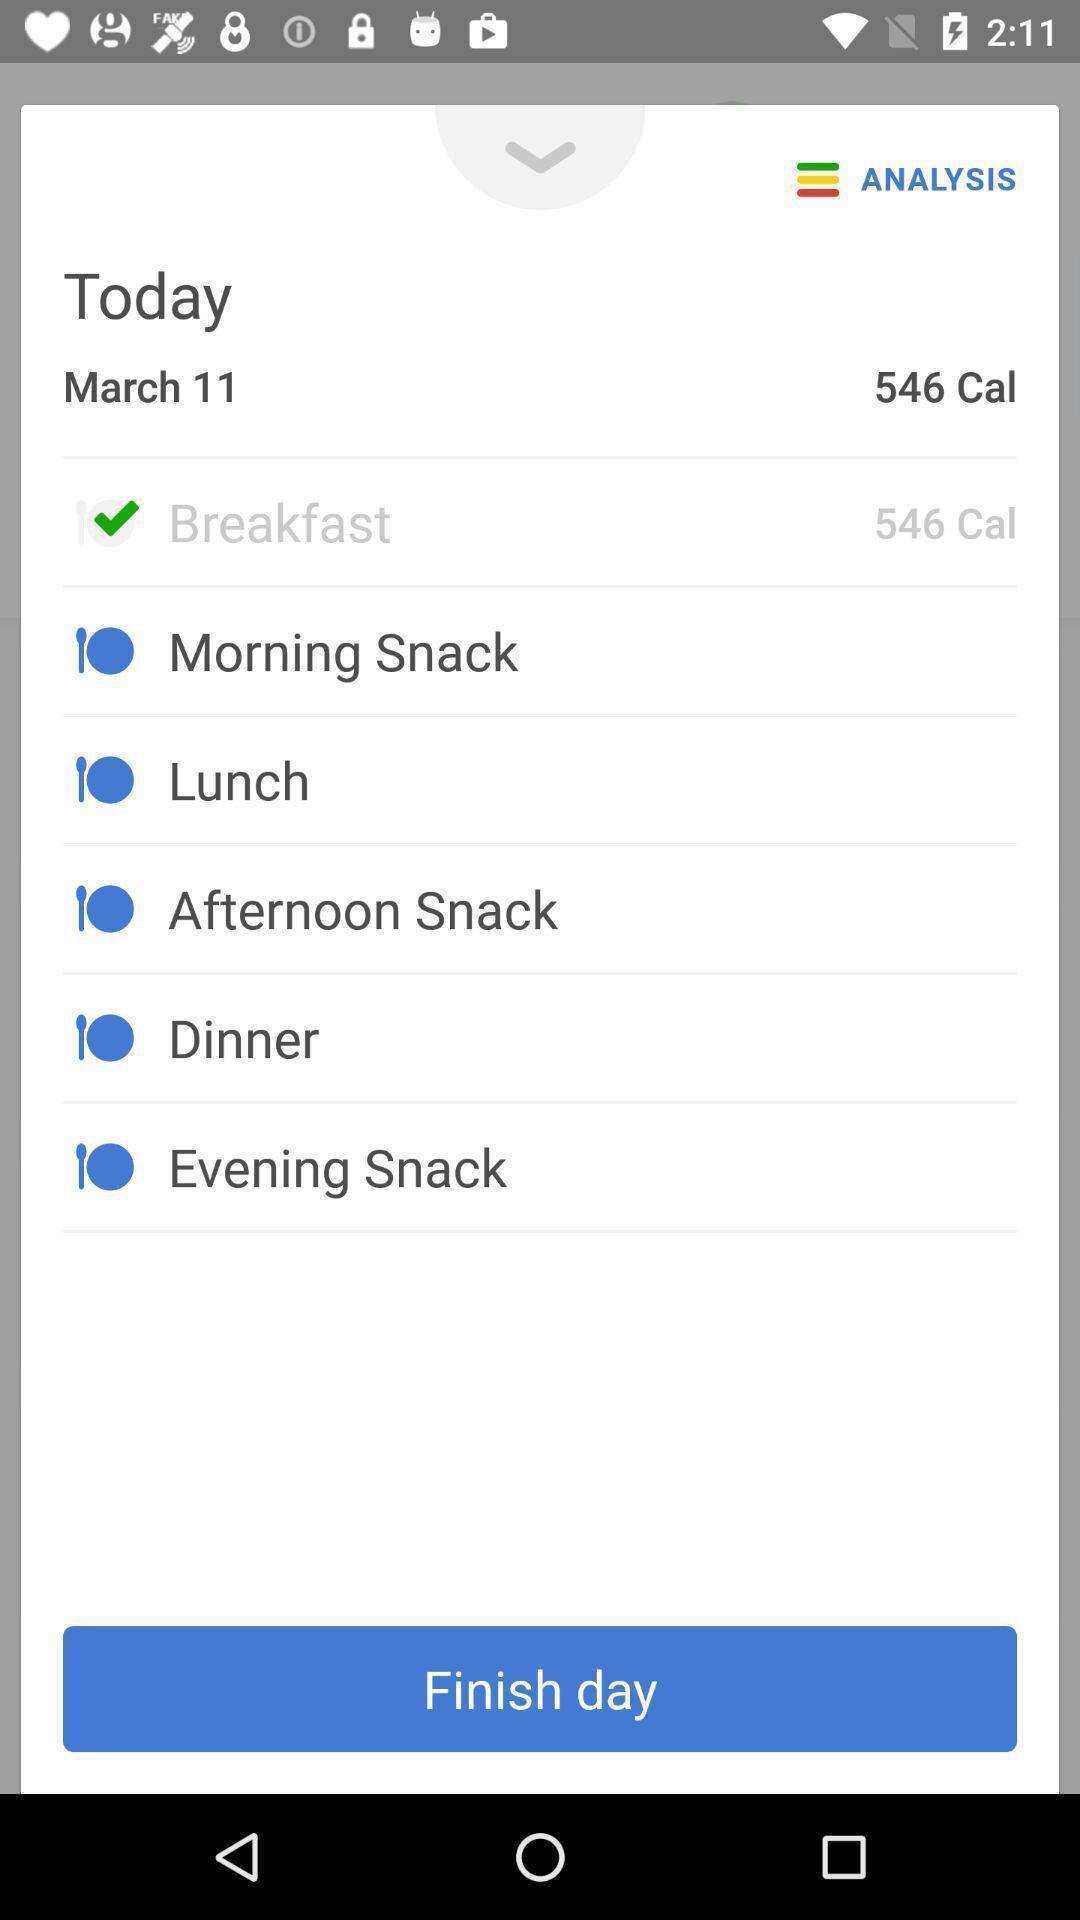Provide a detailed account of this screenshot. Popup showing daily routine in a day. 